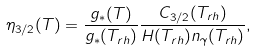<formula> <loc_0><loc_0><loc_500><loc_500>\eta _ { 3 / 2 } ( T ) = \frac { g _ { \ast } ( T ) } { g _ { \ast } ( T _ { r h } ) } \frac { C _ { 3 / 2 } ( T _ { r h } ) } { H ( T _ { r h } ) n _ { \gamma } ( T _ { r h } ) } ,</formula> 